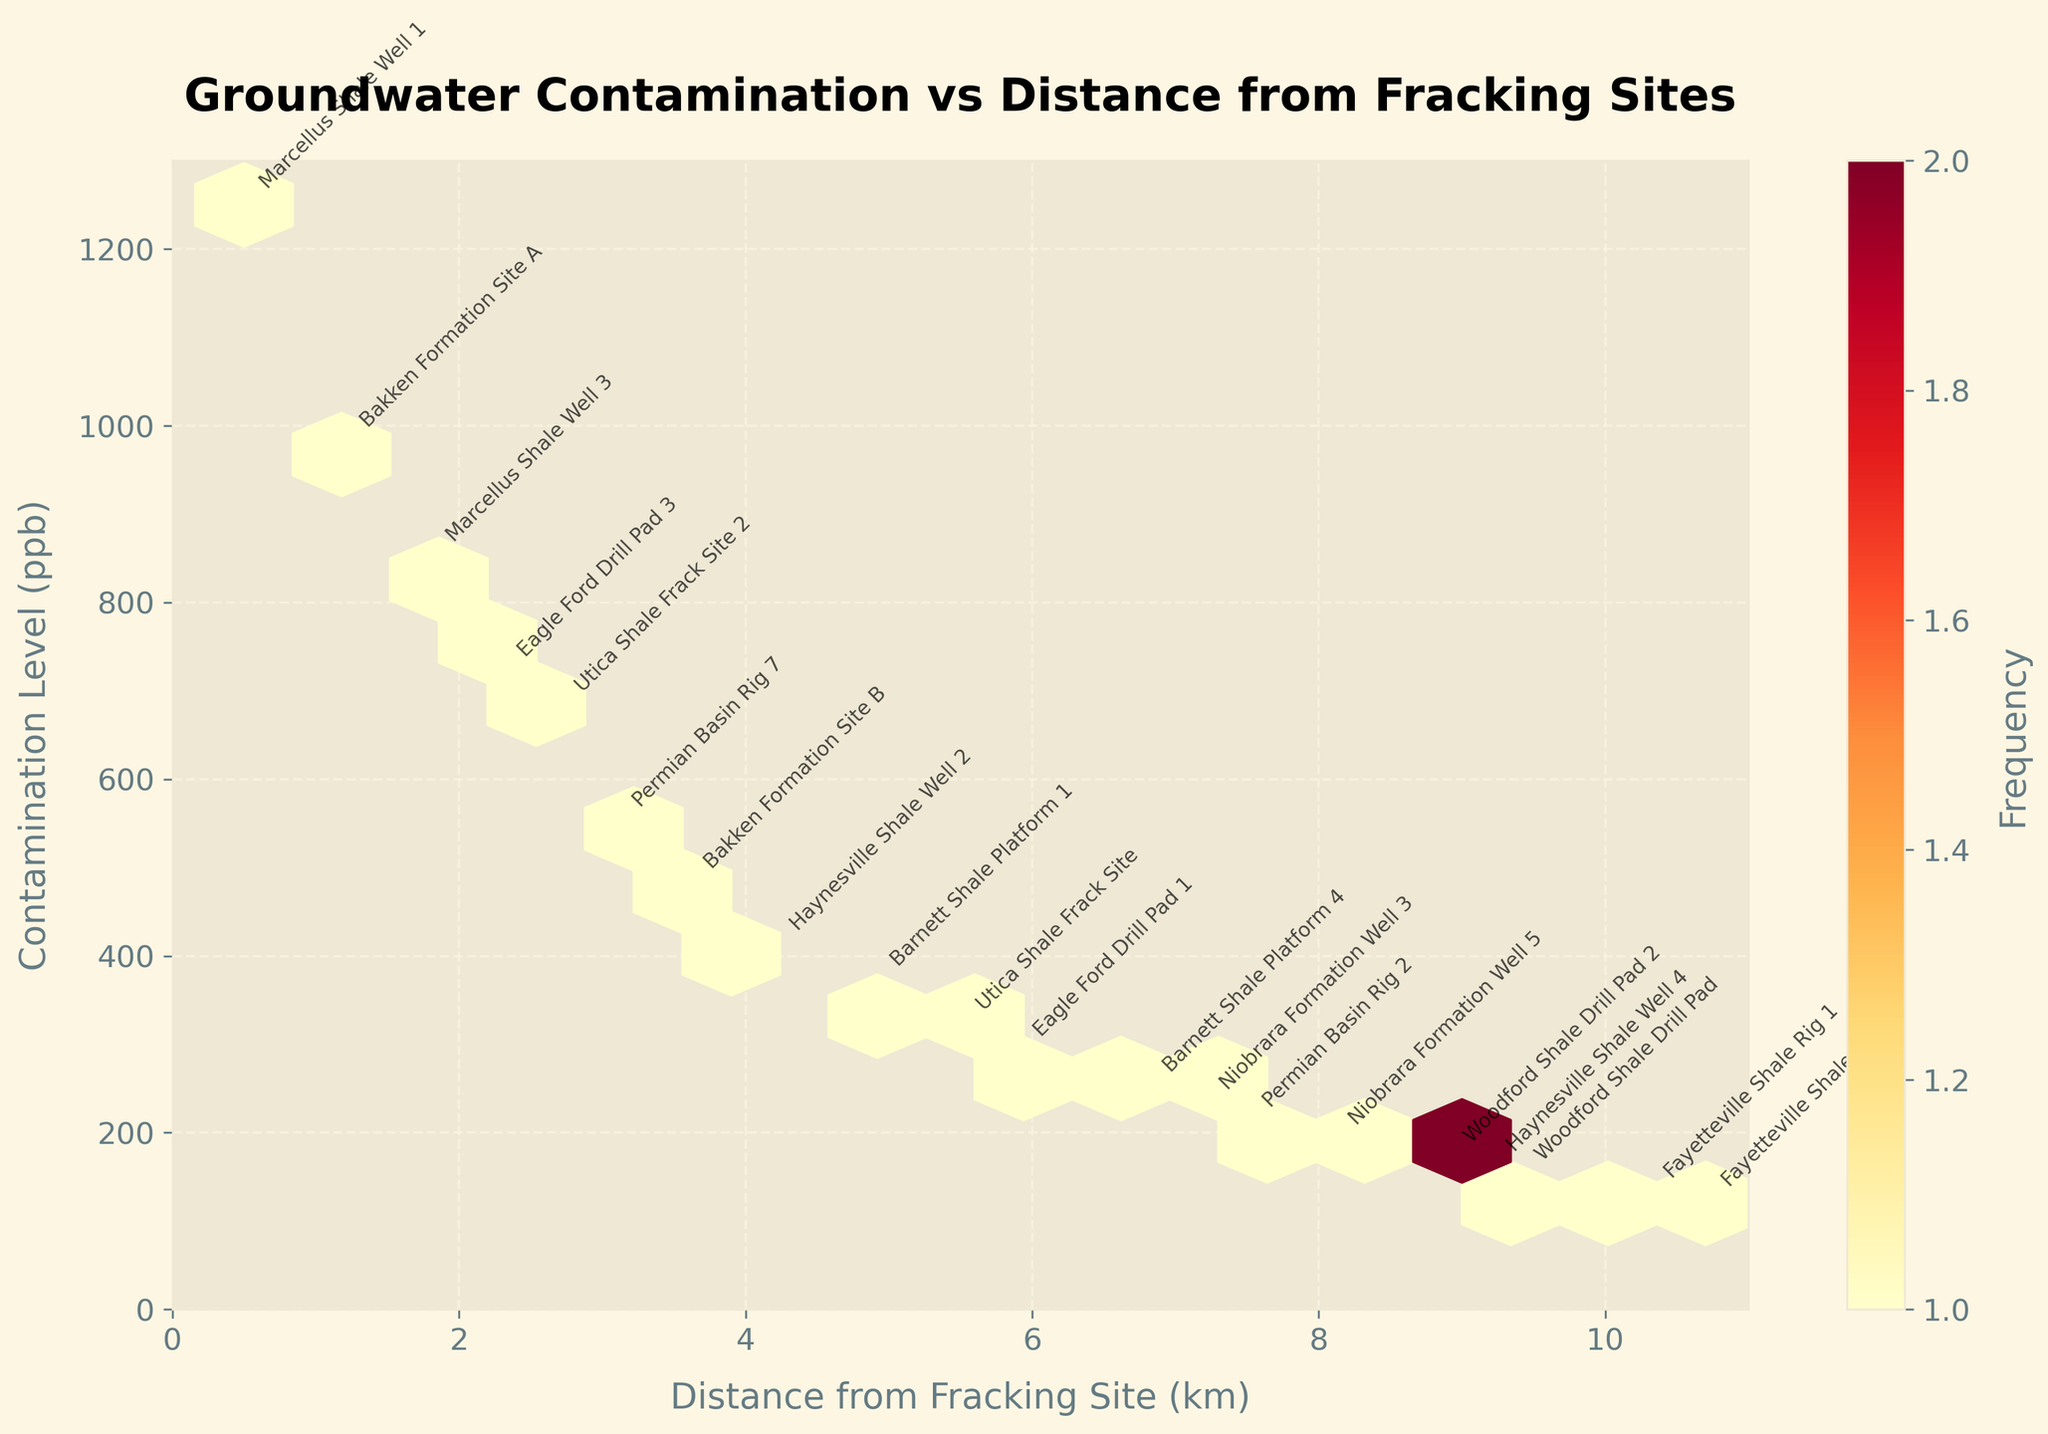How many hexagons are visible in the plot? You can simply count the visible hexagons. These represent bins where data points are clustered.
Answer: 15 What is the title of the plot? The title is stated at the top of the figure in a larger font size.
Answer: Groundwater Contamination vs Distance from Fracking Sites What is the highest contamination level recorded? Look at the y-axis and identify the highest point on the plot. The highest data point represents the highest contamination level.
Answer: 1250 ppb Which site has the lowest contamination level? Look at the annotated labels and find the site corresponding to the smallest value on the y-axis.
Answer: Fayetteville Shale Rig 6 What is the color indicating the highest density of data points? Check the legend (color bar) and identify the color indicating the highest frequency. -- Usually a darker or more intense color in a sequential color map.
Answer: Dark Red How many data points are between 3 km and 5 km from the fracking site? Identify the hexagons between the 3 km and 5 km marks on the x-axis and count the labels or frequency within these hexagons.
Answer: 5 Compare the contamination levels at distances of 0.5 km and 10.7 km from the fracking site. Which one is higher and by how much? Find the points labeled for these distances and compare their y-values (contamination levels). The higher value at 0.5 km is 1250 ppb and at 10.7 km it’s 120 ppb. Subtract the smaller value from the larger.
Answer: 0.5 km is higher by 1130 ppb Is there any trend visible in the plot between distance from fracking sites and contamination levels? Observe the overall distribution and direction of the hexagons and data points. It can be noted that contamination levels tend to decrease as the distance increases.
Answer: Contamination decreases with distance Which site groups have contamination levels above 800 ppb? Look for the data points above the 800 ppb mark on the y-axis and check their labels.
Answer: Marcellus Shale Well 1 and Marcellus Shale Well 3 What is the grid size used for the hexbin plot? The grid size refers to the hexbin layout, which is generally labeled or can be inferred from evenly spaced hexagons. In this case, it matches the given code.
Answer: 15 